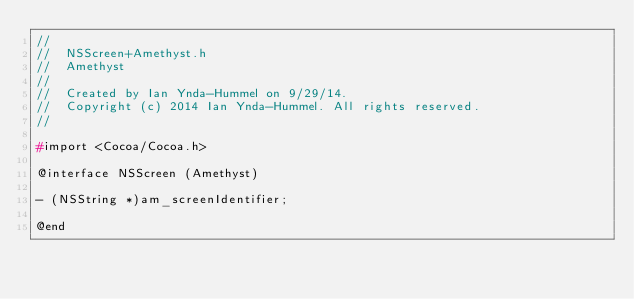<code> <loc_0><loc_0><loc_500><loc_500><_C_>//
//  NSScreen+Amethyst.h
//  Amethyst
//
//  Created by Ian Ynda-Hummel on 9/29/14.
//  Copyright (c) 2014 Ian Ynda-Hummel. All rights reserved.
//

#import <Cocoa/Cocoa.h>

@interface NSScreen (Amethyst)

- (NSString *)am_screenIdentifier;

@end
</code> 